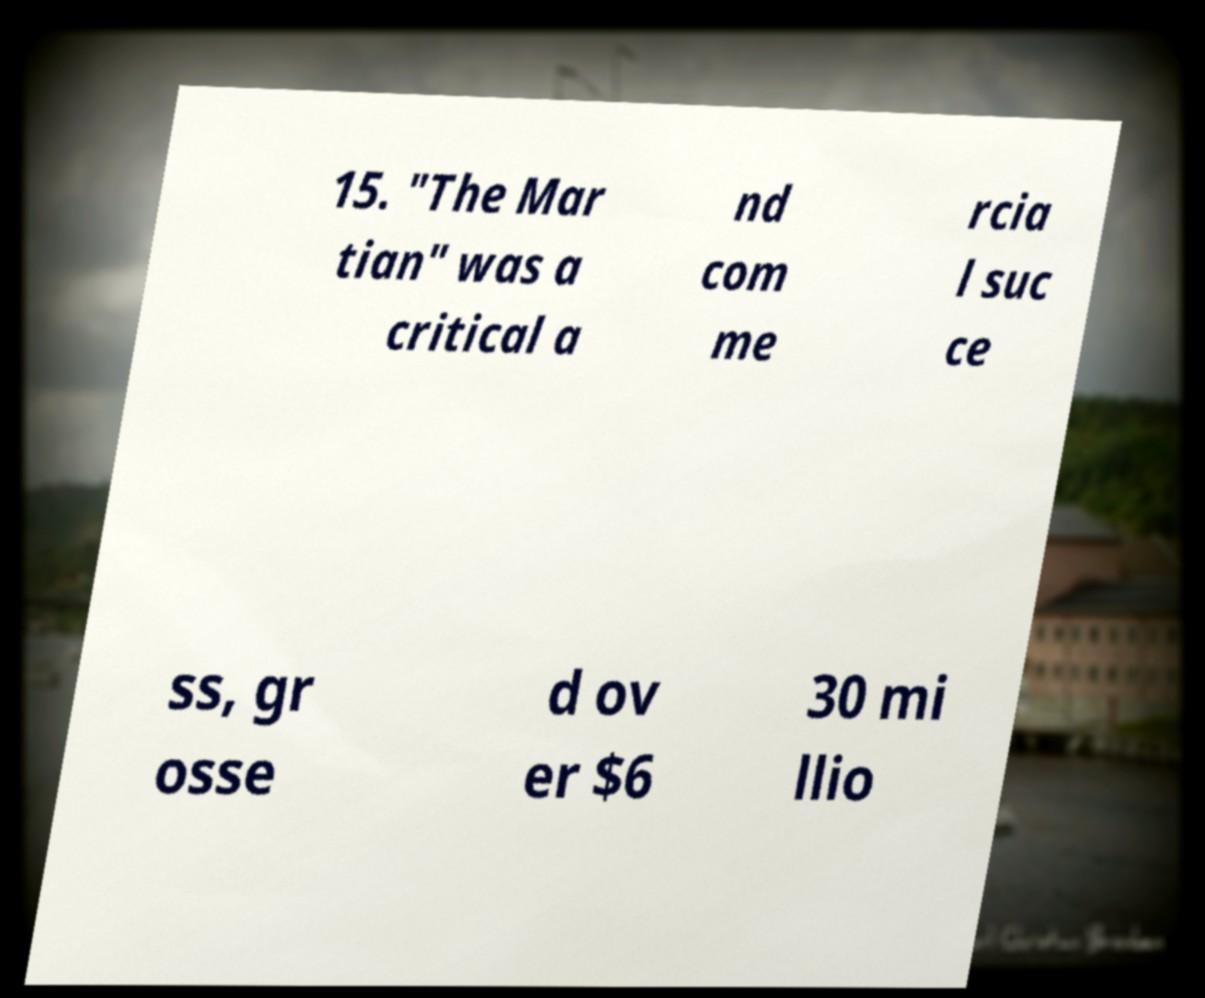I need the written content from this picture converted into text. Can you do that? 15. "The Mar tian" was a critical a nd com me rcia l suc ce ss, gr osse d ov er $6 30 mi llio 